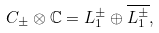Convert formula to latex. <formula><loc_0><loc_0><loc_500><loc_500>C _ { \pm } \otimes \mathbb { C } = L _ { 1 } ^ { \pm } \oplus \overline { L _ { 1 } ^ { \pm } } ,</formula> 